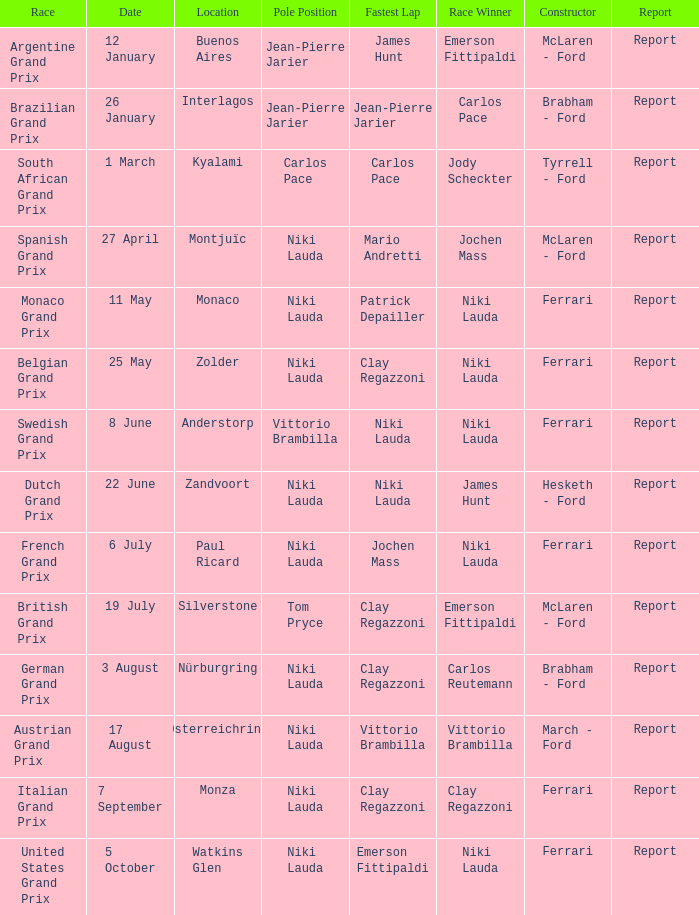Who ran the fastest lap in the team that competed in Zolder, in which Ferrari was the Constructor? Clay Regazzoni. 